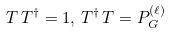<formula> <loc_0><loc_0><loc_500><loc_500>T \, T ^ { \dagger } = { 1 } , \, T ^ { \dagger } \, T = P _ { G } ^ { ( \ell ) }</formula> 